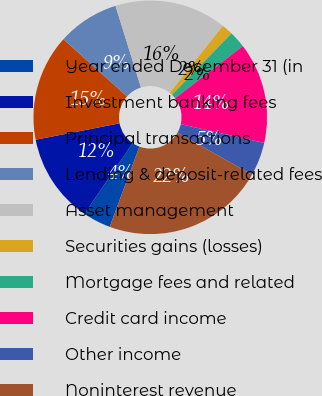Convert chart to OTSL. <chart><loc_0><loc_0><loc_500><loc_500><pie_chart><fcel>Year ended December 31 (in<fcel>Investment banking fees<fcel>Principal transactions<fcel>Lending & deposit-related fees<fcel>Asset management<fcel>Securities gains (losses)<fcel>Mortgage fees and related<fcel>Credit card income<fcel>Other income<fcel>Noninterest revenue<nl><fcel>3.88%<fcel>12.4%<fcel>14.73%<fcel>8.53%<fcel>15.5%<fcel>1.55%<fcel>2.33%<fcel>13.95%<fcel>4.65%<fcel>22.48%<nl></chart> 